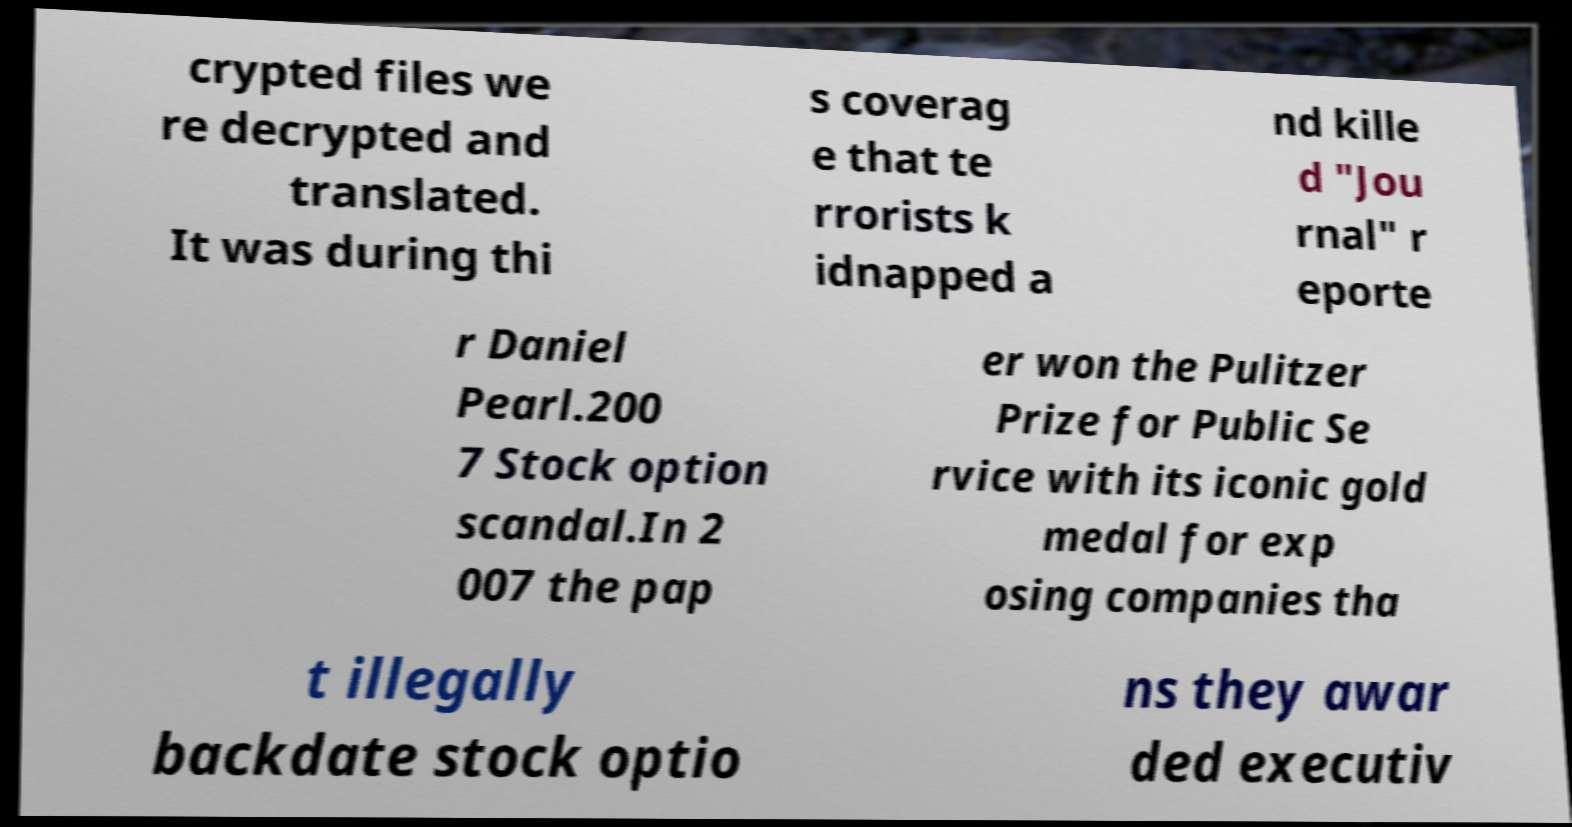Can you read and provide the text displayed in the image?This photo seems to have some interesting text. Can you extract and type it out for me? crypted files we re decrypted and translated. It was during thi s coverag e that te rrorists k idnapped a nd kille d "Jou rnal" r eporte r Daniel Pearl.200 7 Stock option scandal.In 2 007 the pap er won the Pulitzer Prize for Public Se rvice with its iconic gold medal for exp osing companies tha t illegally backdate stock optio ns they awar ded executiv 